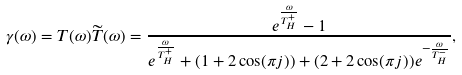Convert formula to latex. <formula><loc_0><loc_0><loc_500><loc_500>\gamma ( \omega ) = T ( \omega ) \widetilde { T } ( \omega ) = \frac { e ^ { \frac { \omega } { T _ { H } ^ { + } } } - 1 } { e ^ { \frac { \omega } { T _ { H } ^ { + } } } + ( 1 + 2 \cos ( \pi j ) ) + ( 2 + 2 \cos ( \pi j ) ) e ^ { - \frac { \omega } { T _ { H } ^ { - } } } } ,</formula> 